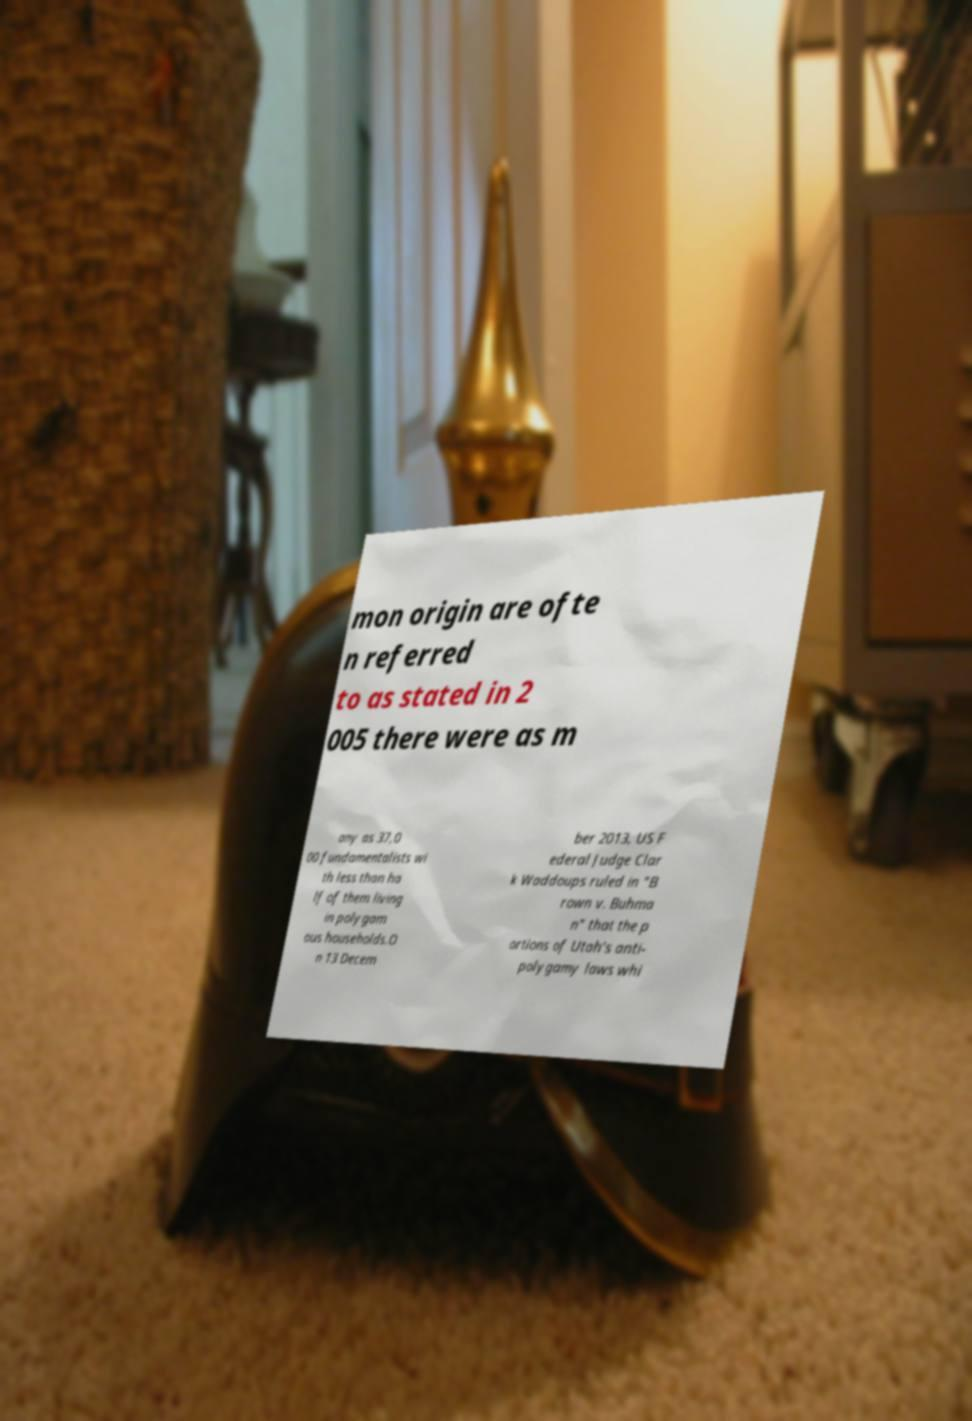Can you read and provide the text displayed in the image?This photo seems to have some interesting text. Can you extract and type it out for me? mon origin are ofte n referred to as stated in 2 005 there were as m any as 37,0 00 fundamentalists wi th less than ha lf of them living in polygam ous households.O n 13 Decem ber 2013, US F ederal Judge Clar k Waddoups ruled in "B rown v. Buhma n" that the p ortions of Utah's anti- polygamy laws whi 